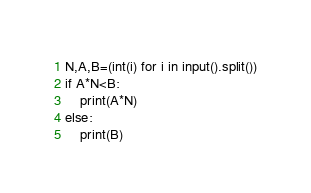Convert code to text. <code><loc_0><loc_0><loc_500><loc_500><_Python_>N,A,B=(int(i) for i in input().split())
if A*N<B:
    print(A*N)
else:
    print(B)</code> 